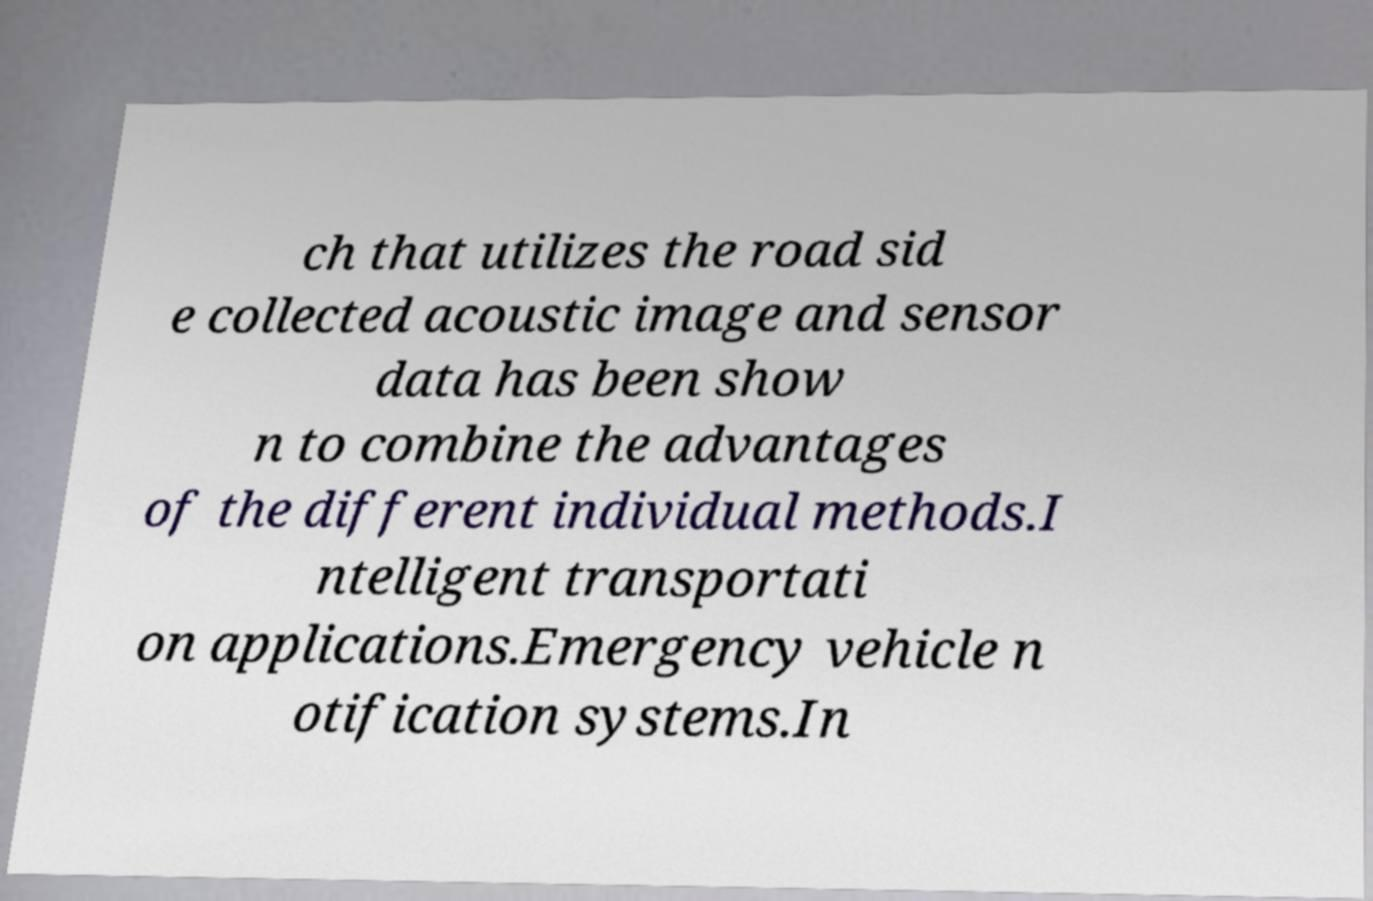For documentation purposes, I need the text within this image transcribed. Could you provide that? ch that utilizes the road sid e collected acoustic image and sensor data has been show n to combine the advantages of the different individual methods.I ntelligent transportati on applications.Emergency vehicle n otification systems.In 